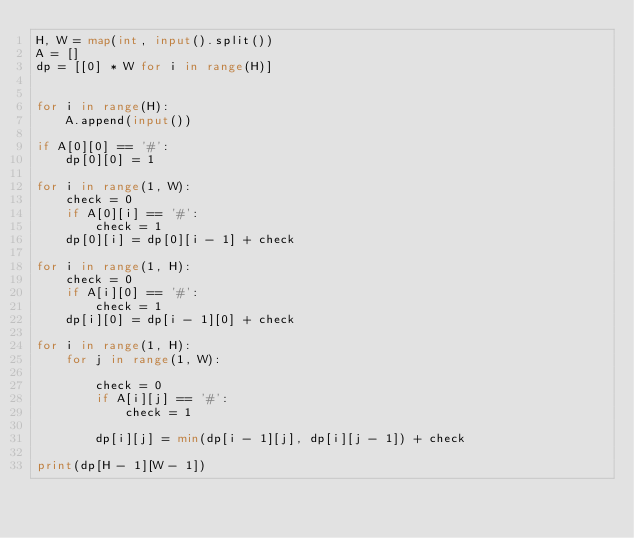Convert code to text. <code><loc_0><loc_0><loc_500><loc_500><_Python_>H, W = map(int, input().split())
A = []
dp = [[0] * W for i in range(H)]


for i in range(H):
    A.append(input())

if A[0][0] == '#':
    dp[0][0] = 1

for i in range(1, W):
    check = 0
    if A[0][i] == '#':
        check = 1
    dp[0][i] = dp[0][i - 1] + check

for i in range(1, H):
    check = 0
    if A[i][0] == '#':
        check = 1
    dp[i][0] = dp[i - 1][0] + check

for i in range(1, H):
    for j in range(1, W):

        check = 0
        if A[i][j] == '#':
            check = 1

        dp[i][j] = min(dp[i - 1][j], dp[i][j - 1]) + check

print(dp[H - 1][W - 1])
</code> 